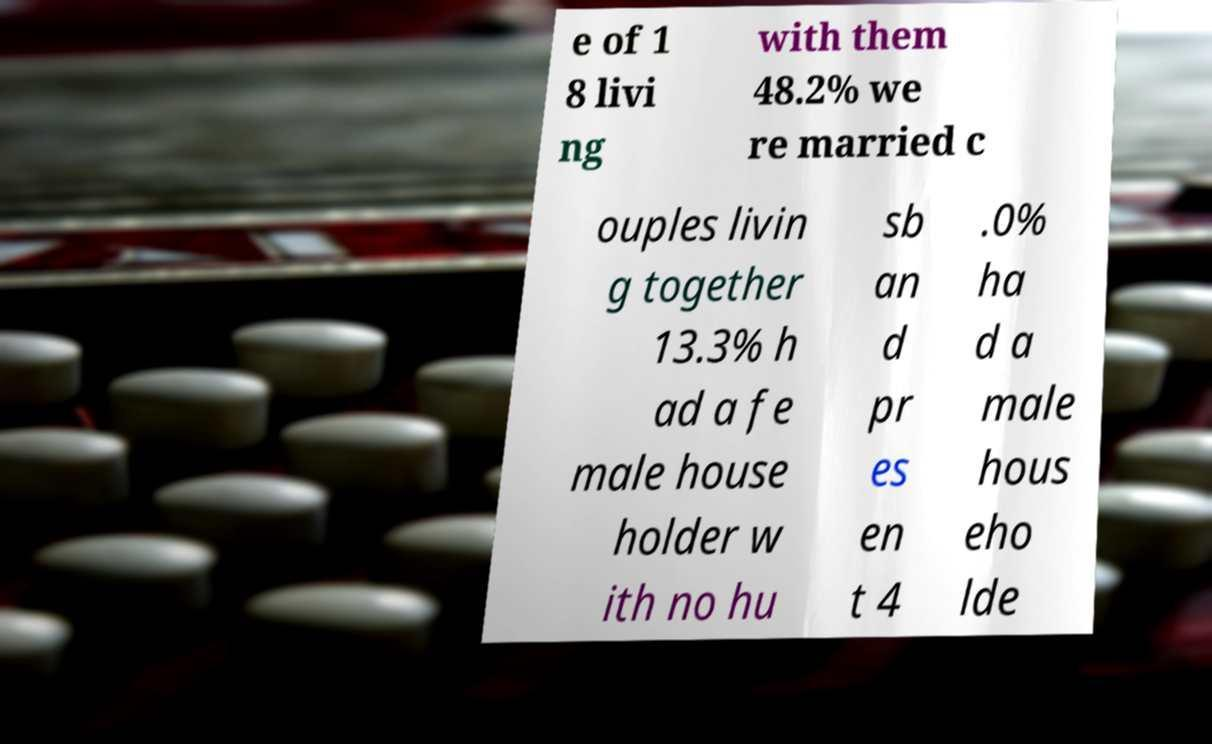Please read and relay the text visible in this image. What does it say? e of 1 8 livi ng with them 48.2% we re married c ouples livin g together 13.3% h ad a fe male house holder w ith no hu sb an d pr es en t 4 .0% ha d a male hous eho lde 